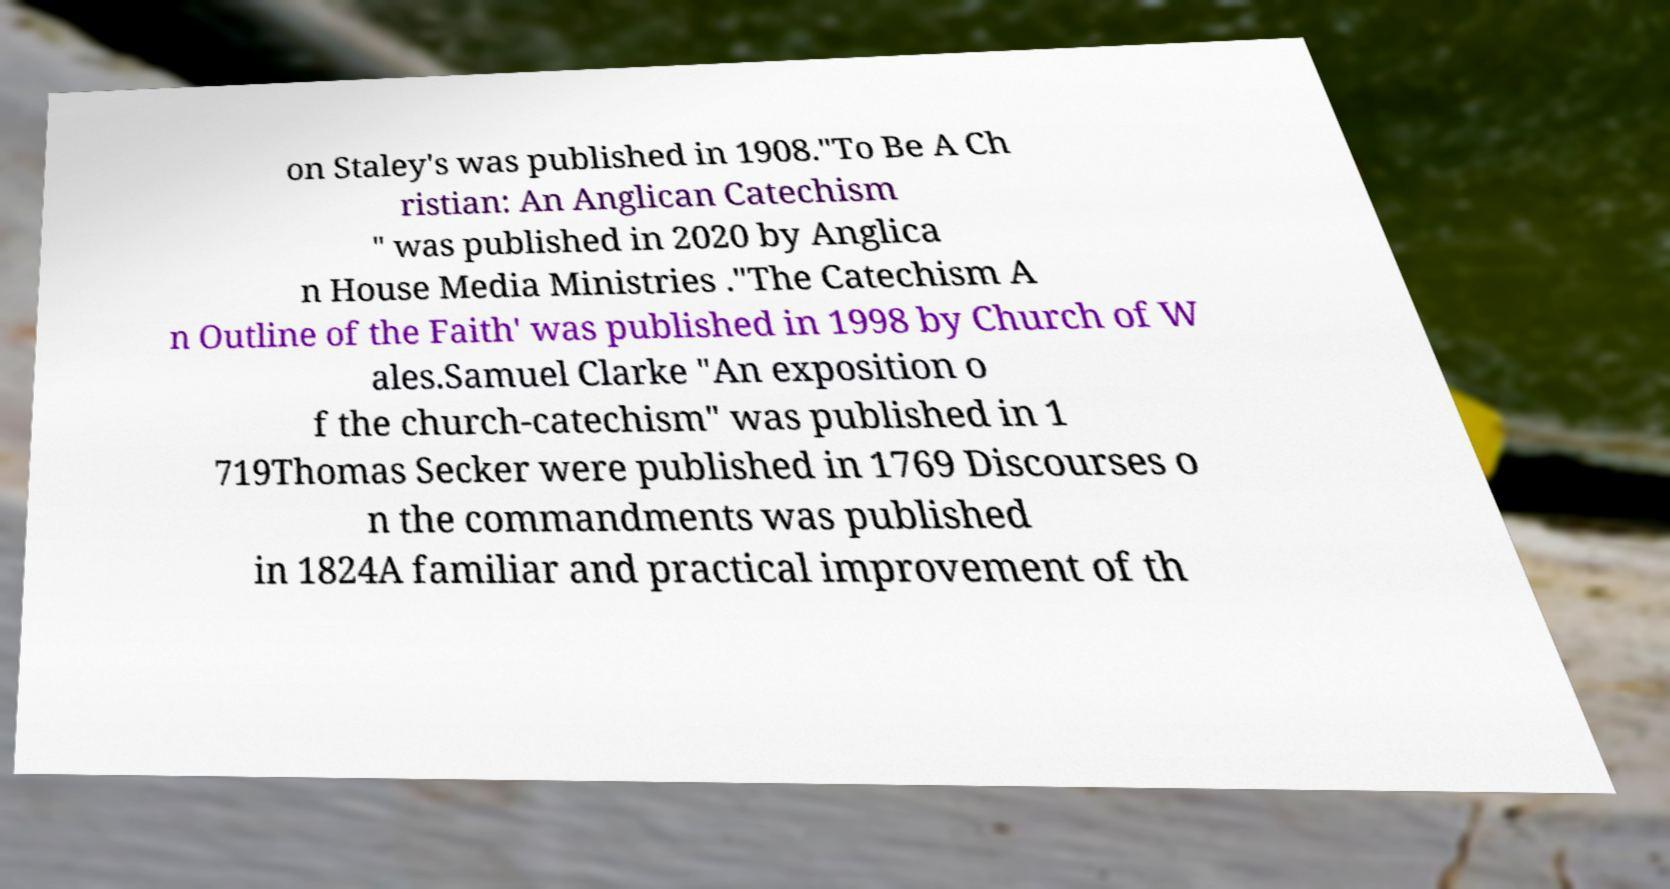Please read and relay the text visible in this image. What does it say? on Staley's was published in 1908."To Be A Ch ristian: An Anglican Catechism " was published in 2020 by Anglica n House Media Ministries ."The Catechism A n Outline of the Faith' was published in 1998 by Church of W ales.Samuel Clarke "An exposition o f the church-catechism" was published in 1 719Thomas Secker were published in 1769 Discourses o n the commandments was published in 1824A familiar and practical improvement of th 